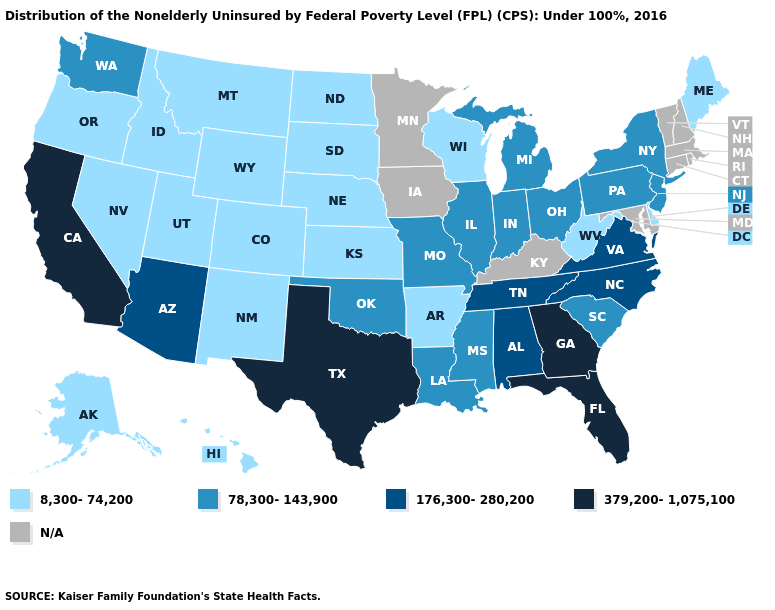Name the states that have a value in the range 8,300-74,200?
Give a very brief answer. Alaska, Arkansas, Colorado, Delaware, Hawaii, Idaho, Kansas, Maine, Montana, Nebraska, Nevada, New Mexico, North Dakota, Oregon, South Dakota, Utah, West Virginia, Wisconsin, Wyoming. Which states have the lowest value in the USA?
Give a very brief answer. Alaska, Arkansas, Colorado, Delaware, Hawaii, Idaho, Kansas, Maine, Montana, Nebraska, Nevada, New Mexico, North Dakota, Oregon, South Dakota, Utah, West Virginia, Wisconsin, Wyoming. Does North Dakota have the lowest value in the MidWest?
Quick response, please. Yes. Does Georgia have the highest value in the USA?
Short answer required. Yes. What is the value of Wisconsin?
Concise answer only. 8,300-74,200. Does Georgia have the highest value in the USA?
Keep it brief. Yes. Which states have the highest value in the USA?
Short answer required. California, Florida, Georgia, Texas. Which states have the highest value in the USA?
Concise answer only. California, Florida, Georgia, Texas. What is the value of Alabama?
Be succinct. 176,300-280,200. What is the highest value in states that border Iowa?
Short answer required. 78,300-143,900. What is the value of New Hampshire?
Concise answer only. N/A. Does the map have missing data?
Give a very brief answer. Yes. 